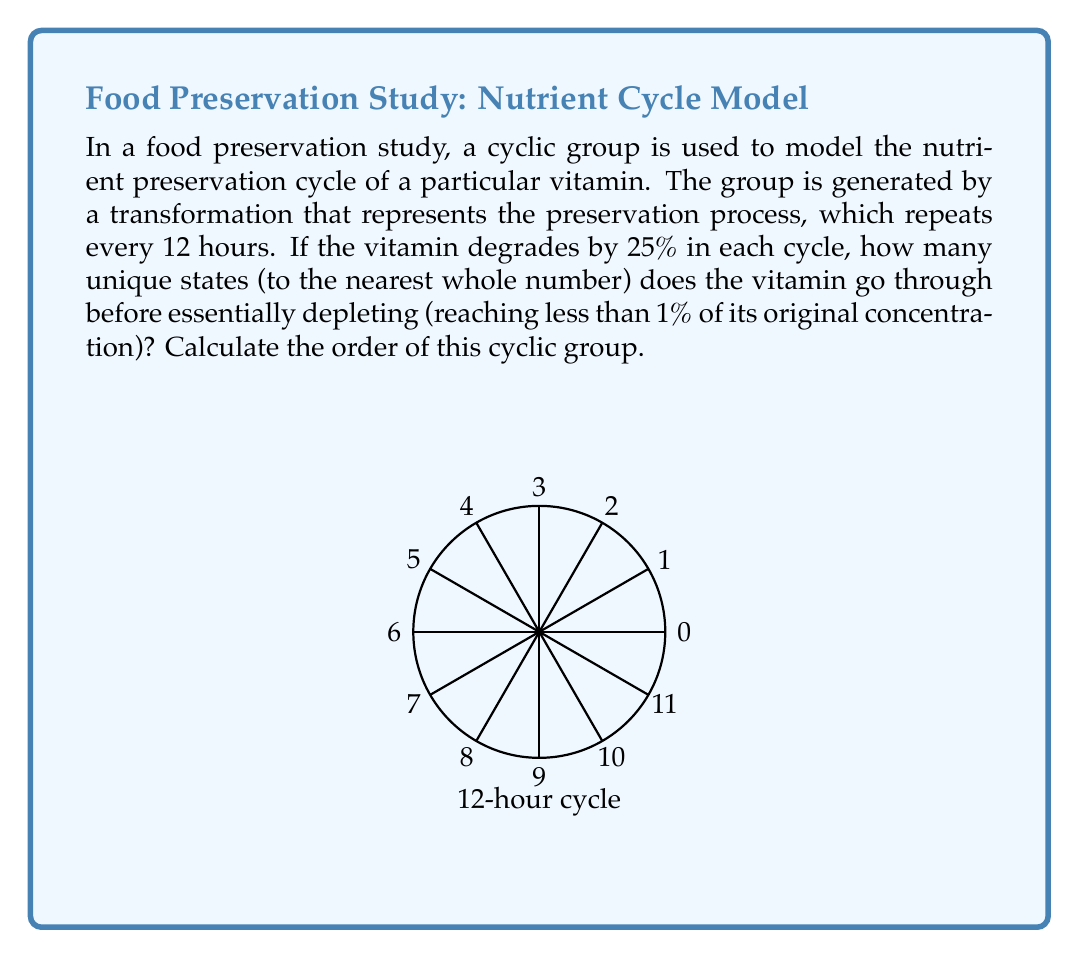Show me your answer to this math problem. Let's approach this step-by-step:

1) Let $x$ be the fraction of the vitamin remaining after each cycle. Then $x = 0.75$ (as 25% is lost each cycle).

2) We need to find $n$ such that $x^n < 0.01$, where $n$ is the number of cycles.

3) This can be expressed as:

   $$(0.75)^n < 0.01$$

4) Taking logarithms of both sides:

   $$n \log(0.75) < \log(0.01)$$

5) Solving for $n$:

   $$n > \frac{\log(0.01)}{\log(0.75)} \approx 16.6$$

6) Since $n$ must be a whole number, we round up to 17.

7) This means the vitamin goes through 17 unique states (including the initial state) before depleting below 1%.

8) In group theory, the order of a cyclic group is equal to the number of unique elements generated by the group operation.

9) Therefore, the order of this cyclic group is 17.
Answer: 17 